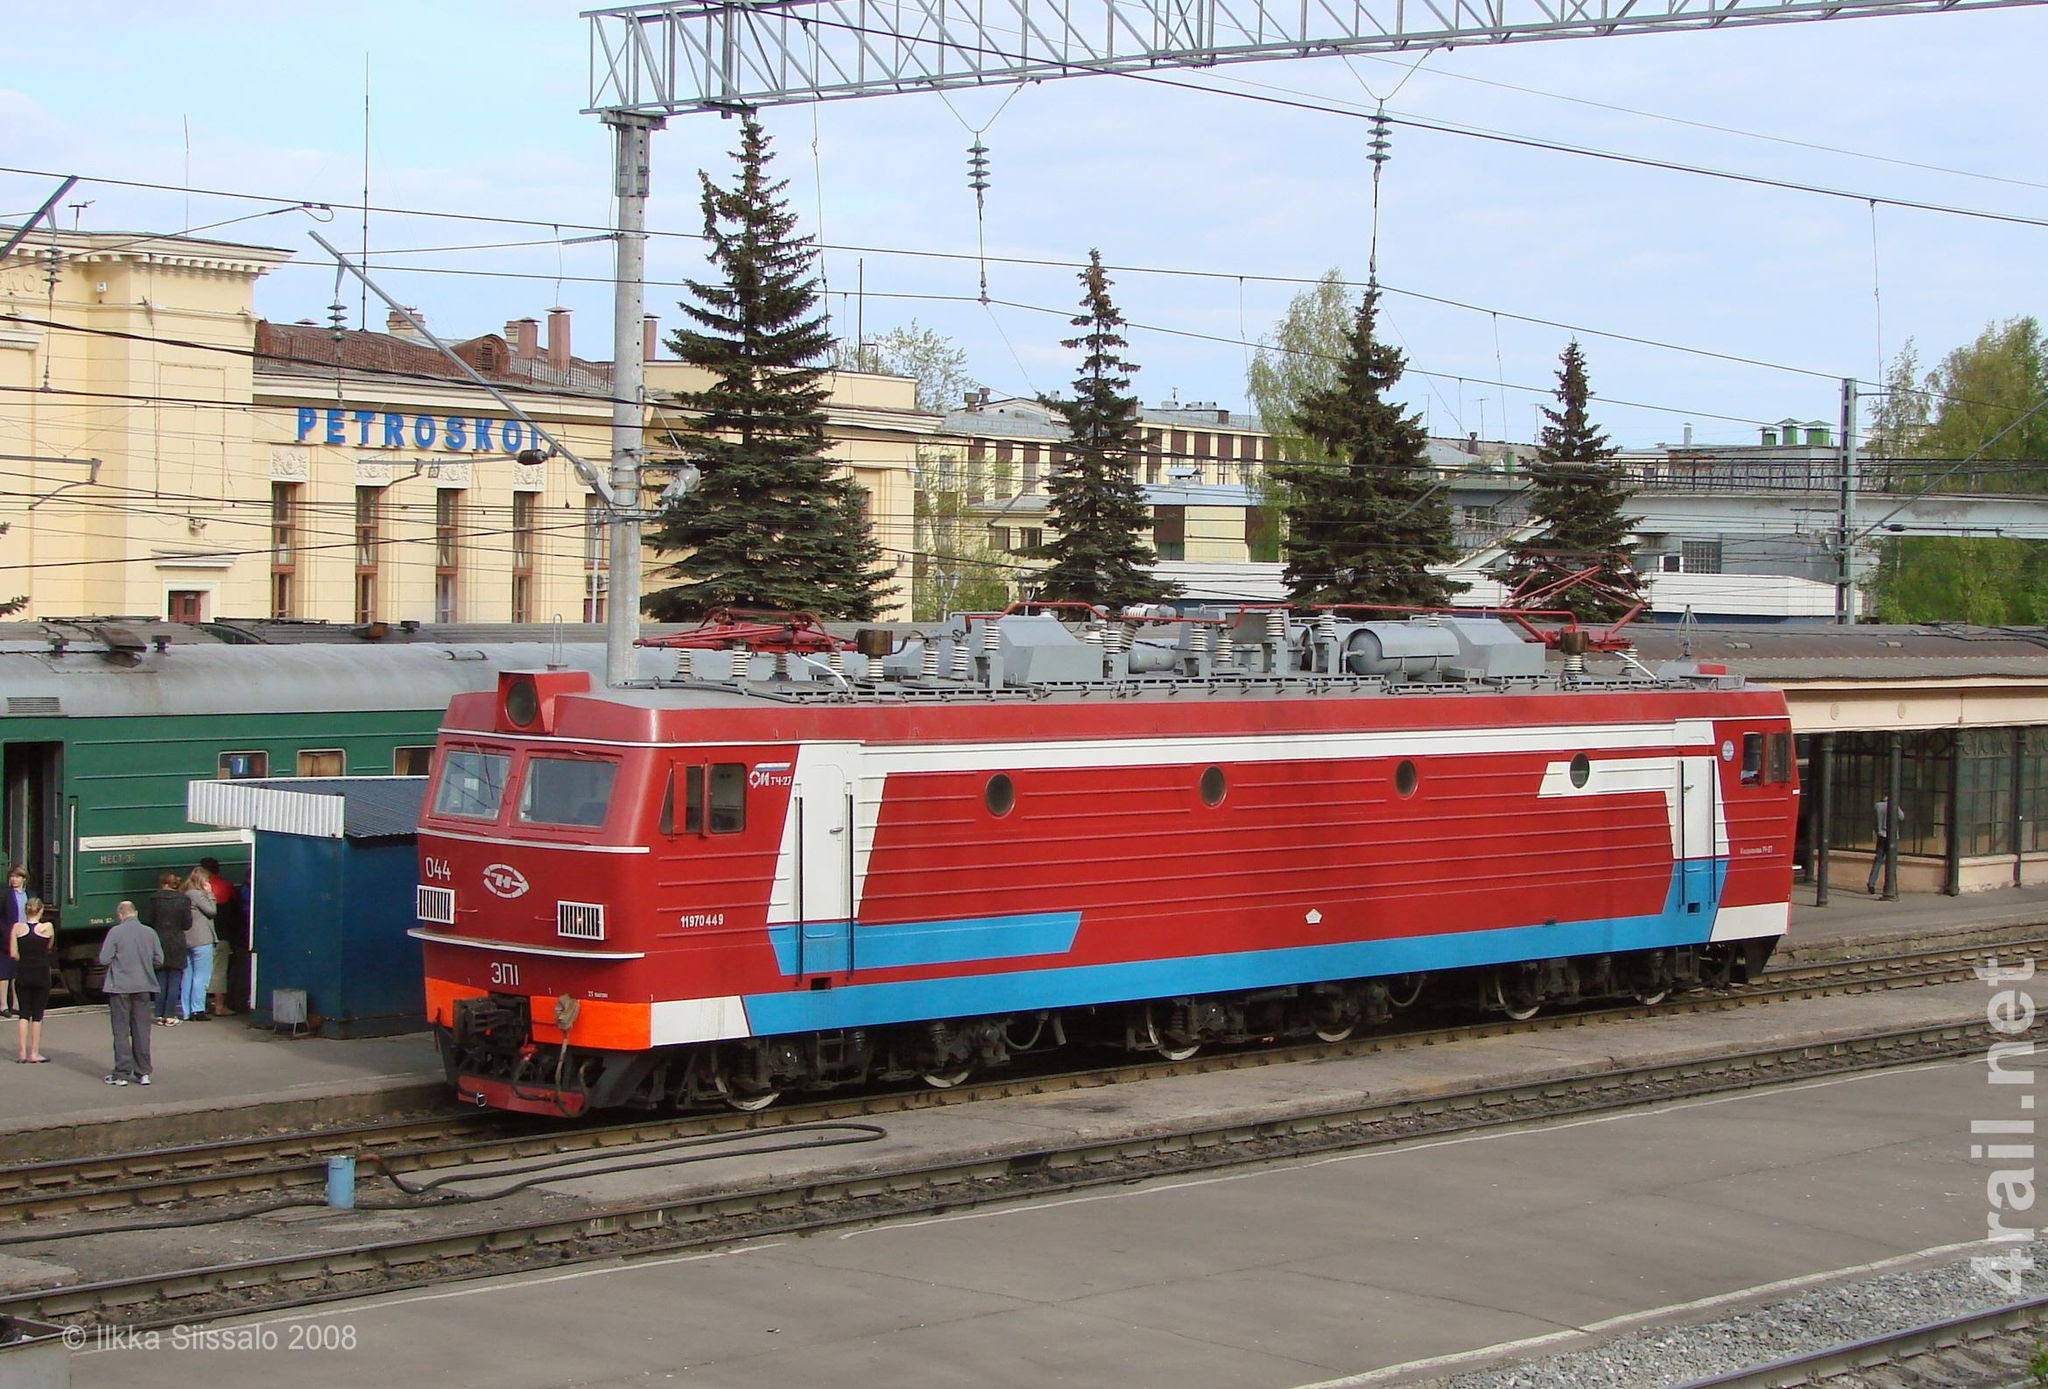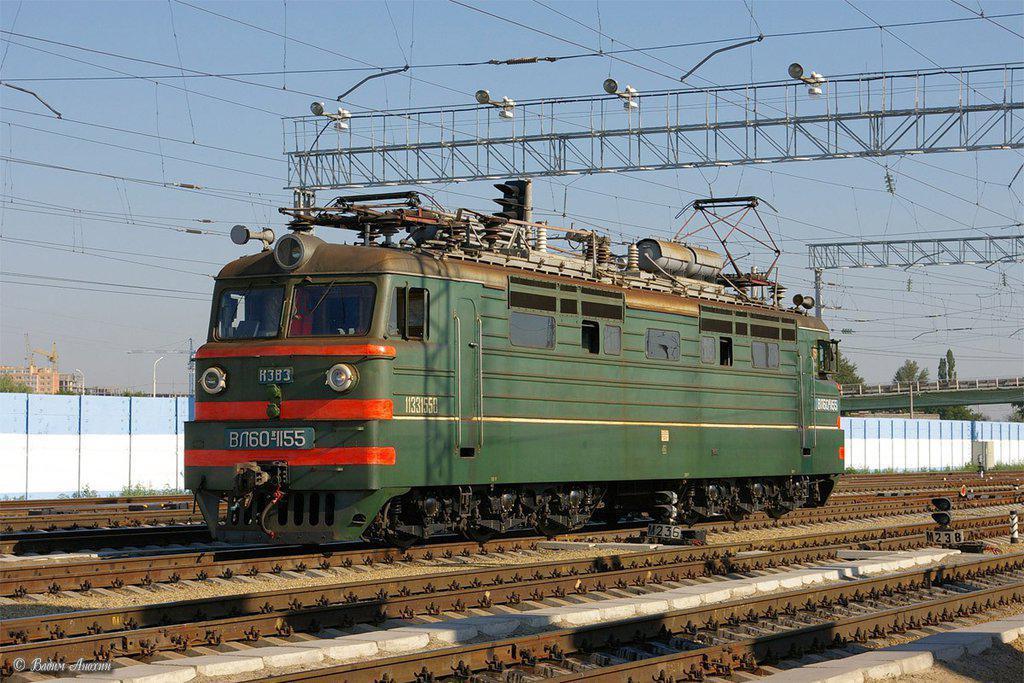The first image is the image on the left, the second image is the image on the right. For the images shown, is this caption "An image shows a dark green train with bright orange stripes across the front." true? Answer yes or no. Yes. The first image is the image on the left, the second image is the image on the right. Considering the images on both sides, is "Both trains are facing and traveling to the right." valid? Answer yes or no. No. 